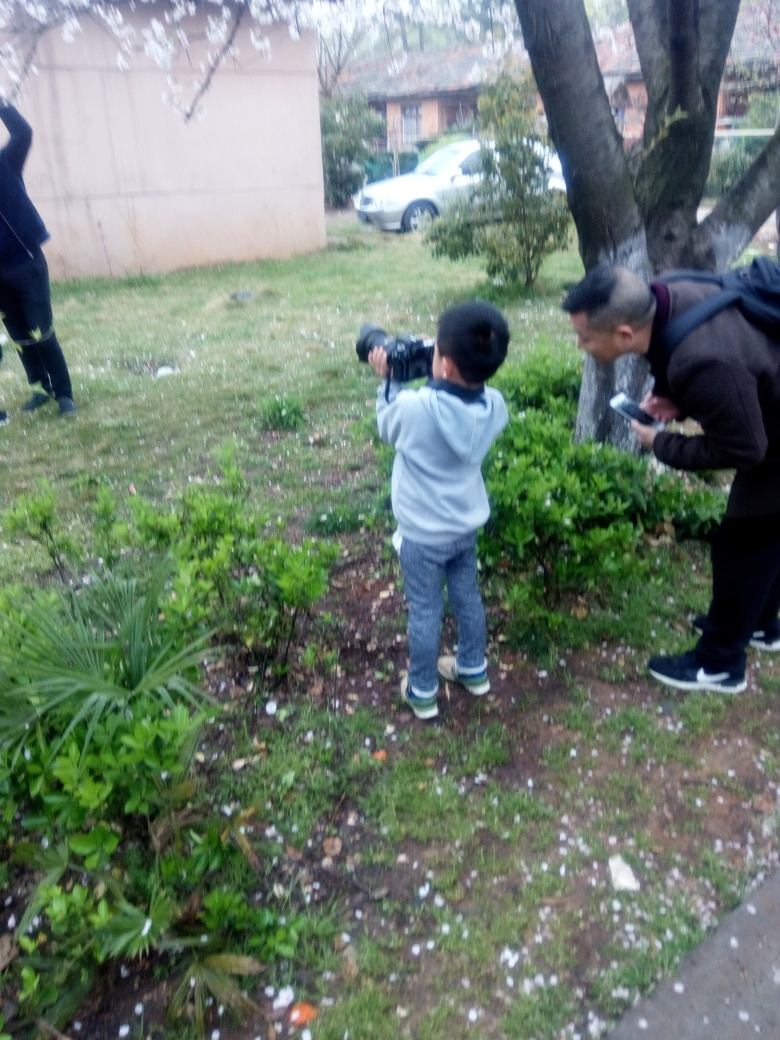Based on the image, what time of year does it seem to be? Given the presence of blooming trees and the attire of the individuals, it seems to be spring. The falling petals and the vegetation suggest a temperate climate during a time of natural renewal. 